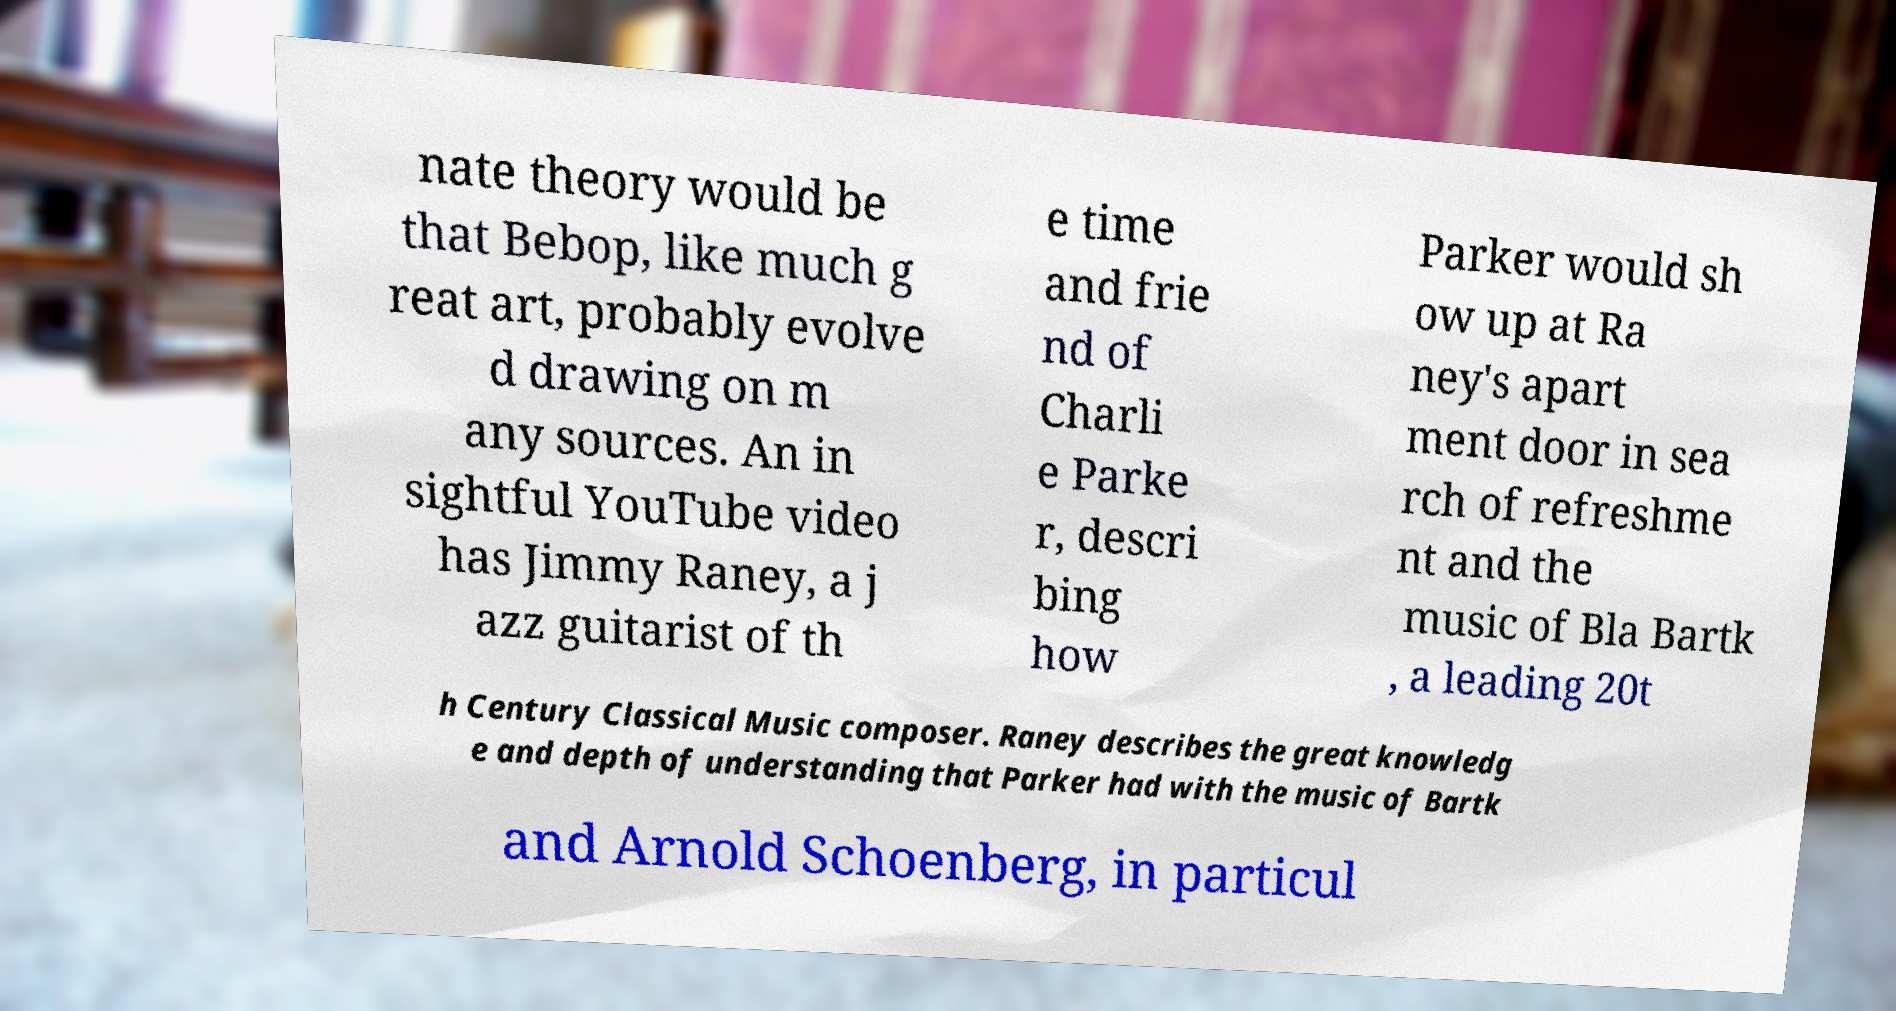I need the written content from this picture converted into text. Can you do that? nate theory would be that Bebop, like much g reat art, probably evolve d drawing on m any sources. An in sightful YouTube video has Jimmy Raney, a j azz guitarist of th e time and frie nd of Charli e Parke r, descri bing how Parker would sh ow up at Ra ney's apart ment door in sea rch of refreshme nt and the music of Bla Bartk , a leading 20t h Century Classical Music composer. Raney describes the great knowledg e and depth of understanding that Parker had with the music of Bartk and Arnold Schoenberg, in particul 